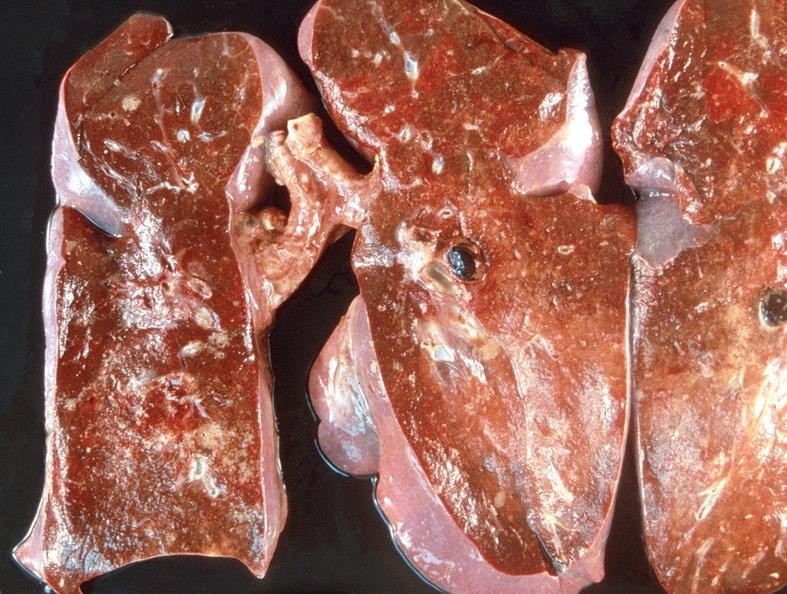s respiratory present?
Answer the question using a single word or phrase. Yes 